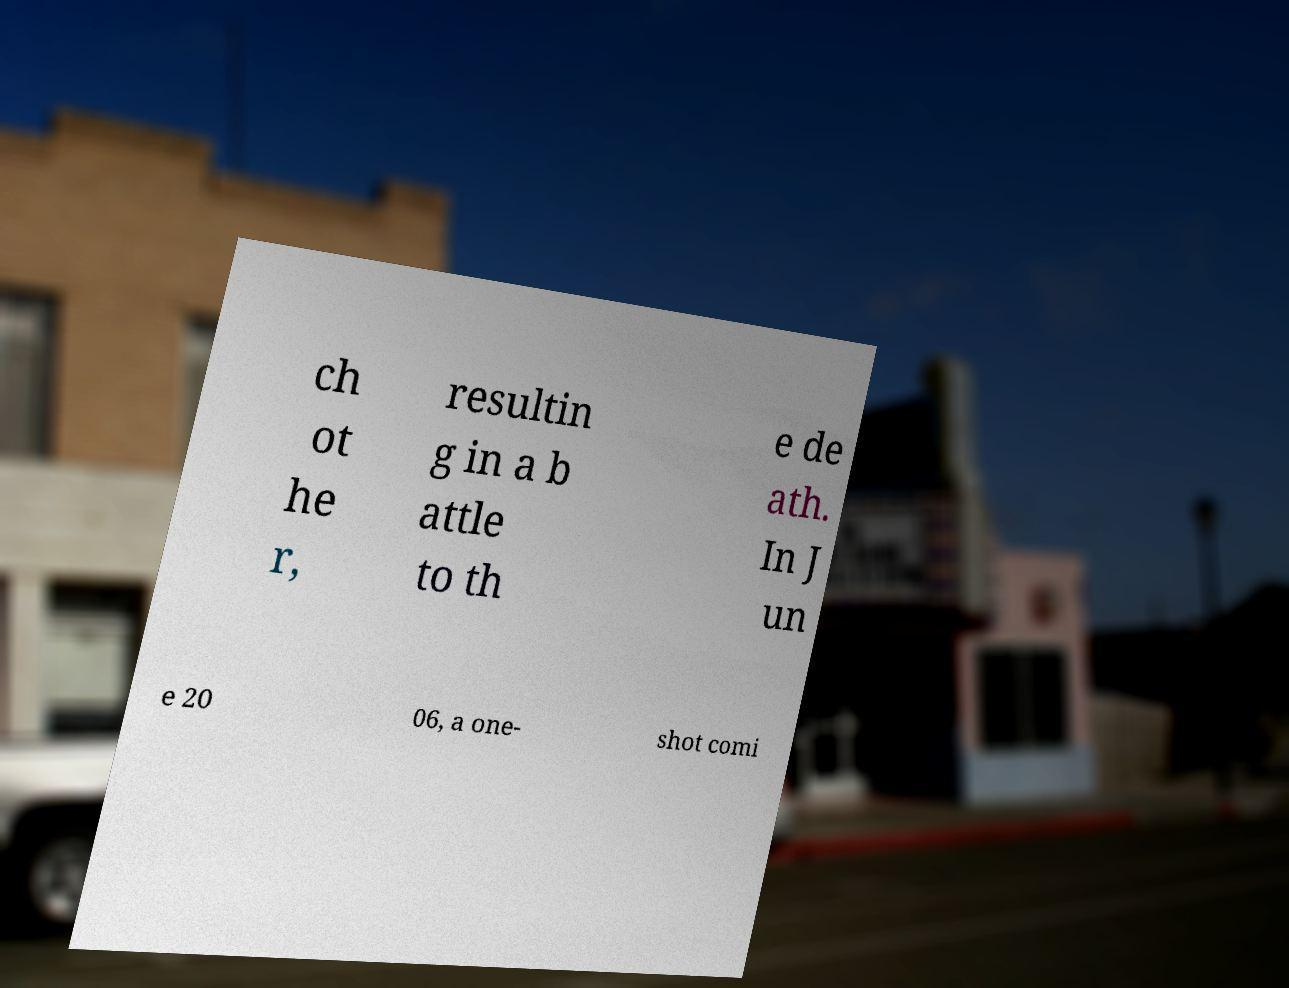Please identify and transcribe the text found in this image. ch ot he r, resultin g in a b attle to th e de ath. In J un e 20 06, a one- shot comi 